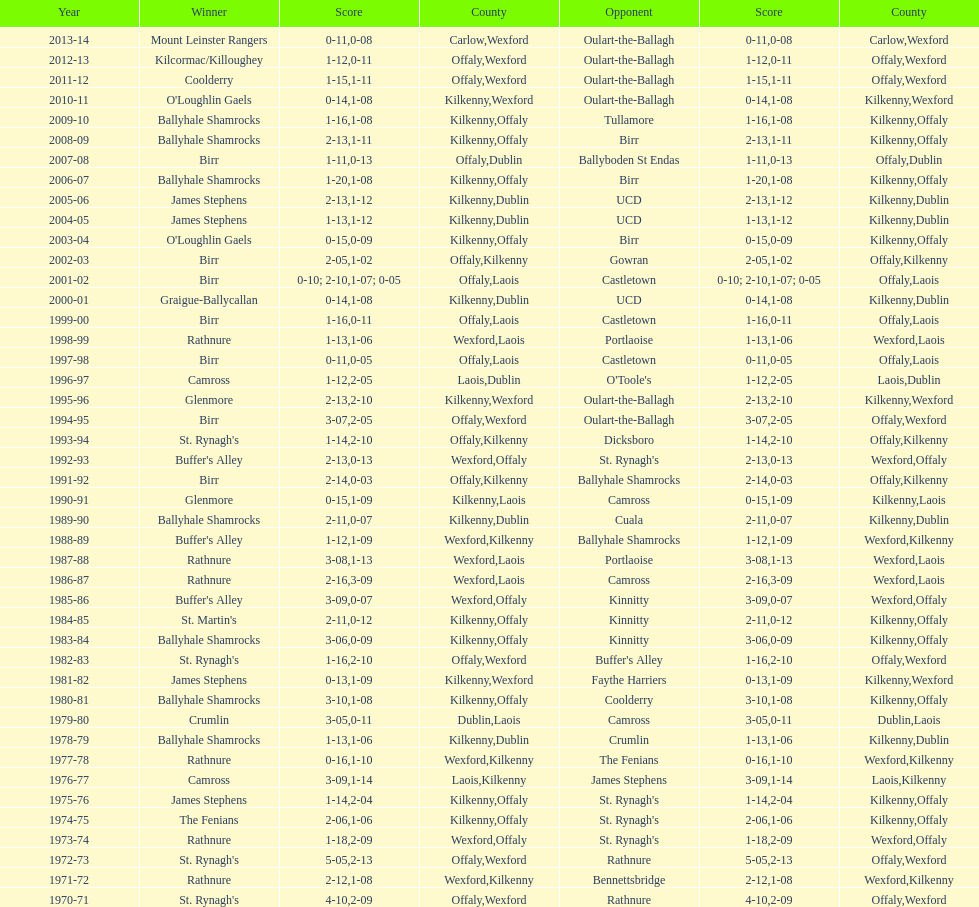In what most recent season was the leinster senior club hurling championships decided by a point difference of under 11? 2007-08. 